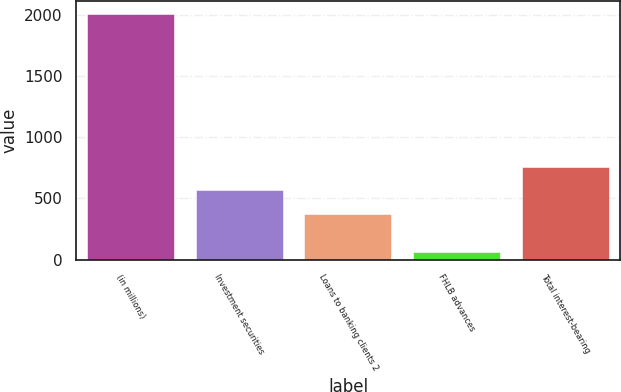Convert chart to OTSL. <chart><loc_0><loc_0><loc_500><loc_500><bar_chart><fcel>(in millions)<fcel>Investment securities<fcel>Loans to banking clients 2<fcel>FHLB advances<fcel>Total interest-bearing<nl><fcel>2010<fcel>565.47<fcel>370.4<fcel>59.3<fcel>760.54<nl></chart> 